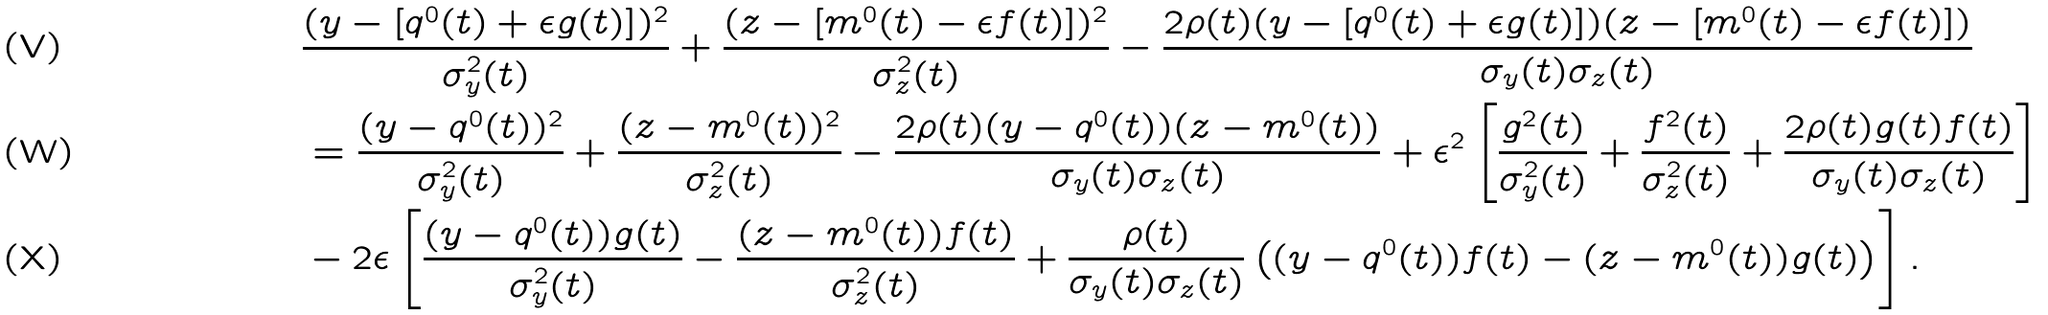<formula> <loc_0><loc_0><loc_500><loc_500>& \frac { ( y - \left [ q ^ { 0 } ( t ) + \epsilon g ( t ) \right ] ) ^ { 2 } } { \sigma ^ { 2 } _ { y } ( t ) } + \frac { ( z - \left [ m ^ { 0 } ( t ) - \epsilon f ( t ) \right ] ) ^ { 2 } } { \sigma ^ { 2 } _ { z } ( t ) } - \frac { 2 \rho ( t ) ( y - \left [ q ^ { 0 } ( t ) + \epsilon g ( t ) \right ] ) ( z - \left [ m ^ { 0 } ( t ) - \epsilon f ( t ) \right ] ) } { \sigma _ { y } ( t ) \sigma _ { z } ( t ) } \\ & = \frac { ( y - q ^ { 0 } ( t ) ) ^ { 2 } } { \sigma ^ { 2 } _ { y } ( t ) } + \frac { ( z - m ^ { 0 } ( t ) ) ^ { 2 } } { \sigma ^ { 2 } _ { z } ( t ) } - \frac { 2 \rho ( t ) ( y - q ^ { 0 } ( t ) ) ( z - m ^ { 0 } ( t ) ) } { \sigma _ { y } ( t ) \sigma _ { z } ( t ) } + \epsilon ^ { 2 } \left [ \frac { g ^ { 2 } ( t ) } { \sigma ^ { 2 } _ { y } ( t ) } + \frac { f ^ { 2 } ( t ) } { \sigma ^ { 2 } _ { z } ( t ) } + \frac { 2 \rho ( t ) g ( t ) f ( t ) } { \sigma _ { y } ( t ) \sigma _ { z } ( t ) } \right ] \\ & - 2 \epsilon \left [ \frac { ( y - q ^ { 0 } ( t ) ) g ( t ) } { \sigma ^ { 2 } _ { y } ( t ) } - \frac { ( z - m ^ { 0 } ( t ) ) f ( t ) } { \sigma ^ { 2 } _ { z } ( t ) } + \frac { \rho ( t ) } { \sigma _ { y } ( t ) \sigma _ { z } ( t ) } \left ( ( y - q ^ { 0 } ( t ) ) f ( t ) - ( z - m ^ { 0 } ( t ) ) g ( t ) \right ) \right ] .</formula> 